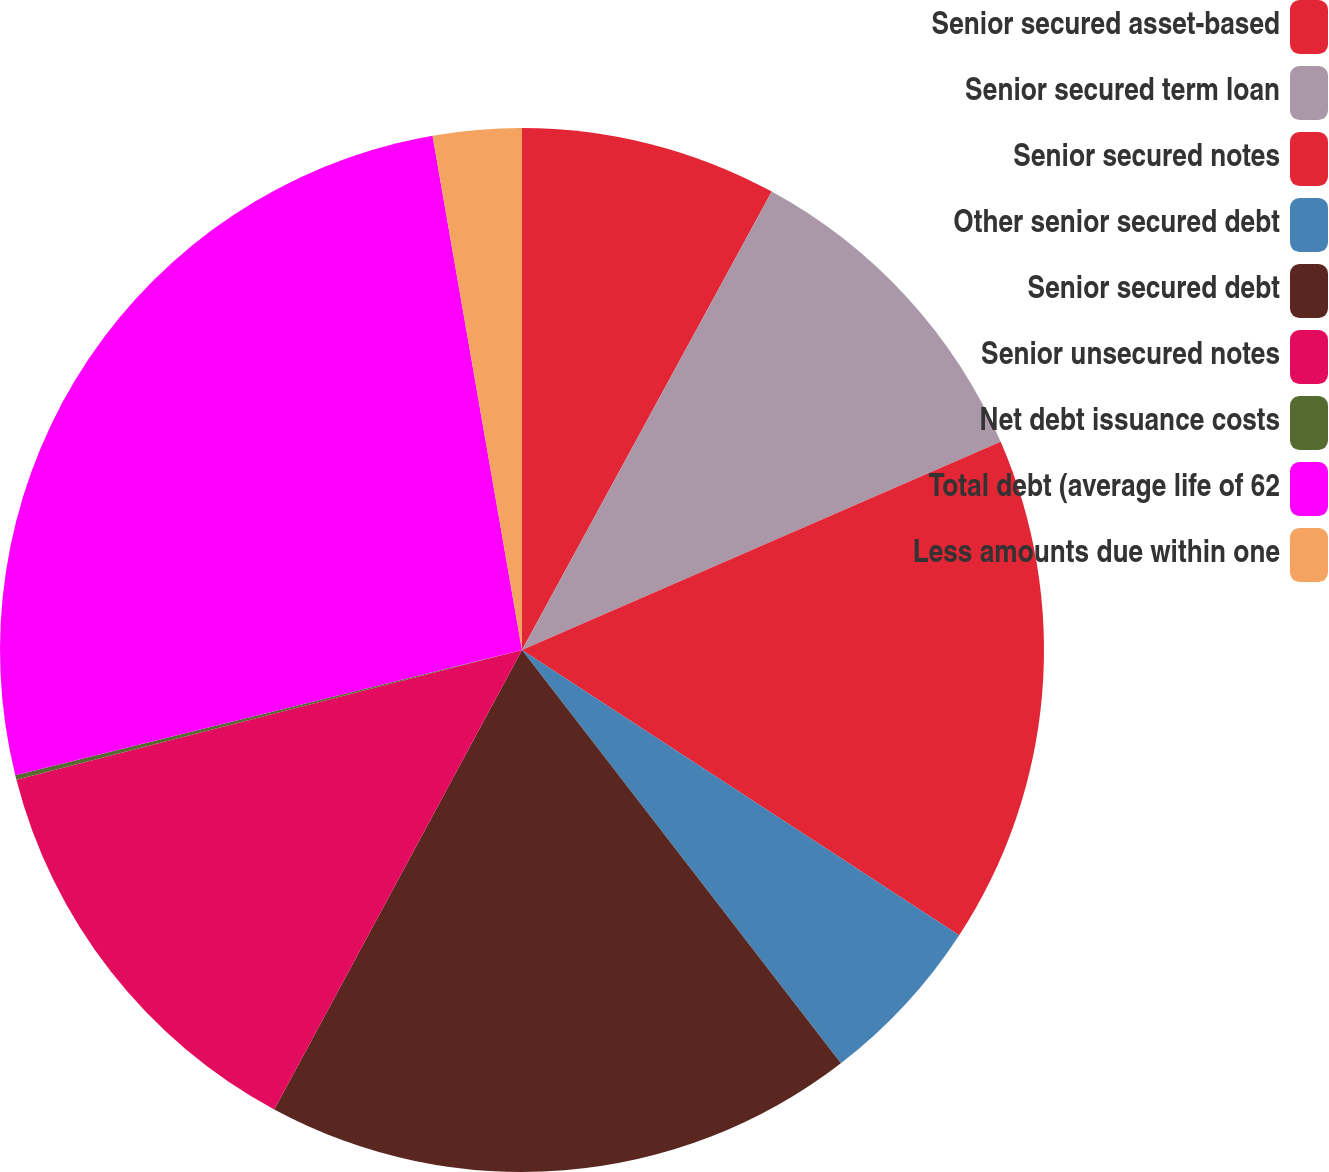Convert chart. <chart><loc_0><loc_0><loc_500><loc_500><pie_chart><fcel>Senior secured asset-based<fcel>Senior secured term loan<fcel>Senior secured notes<fcel>Other senior secured debt<fcel>Senior secured debt<fcel>Senior unsecured notes<fcel>Net debt issuance costs<fcel>Total debt (average life of 62<fcel>Less amounts due within one<nl><fcel>7.94%<fcel>10.53%<fcel>15.73%<fcel>5.34%<fcel>18.33%<fcel>13.13%<fcel>0.14%<fcel>26.12%<fcel>2.74%<nl></chart> 